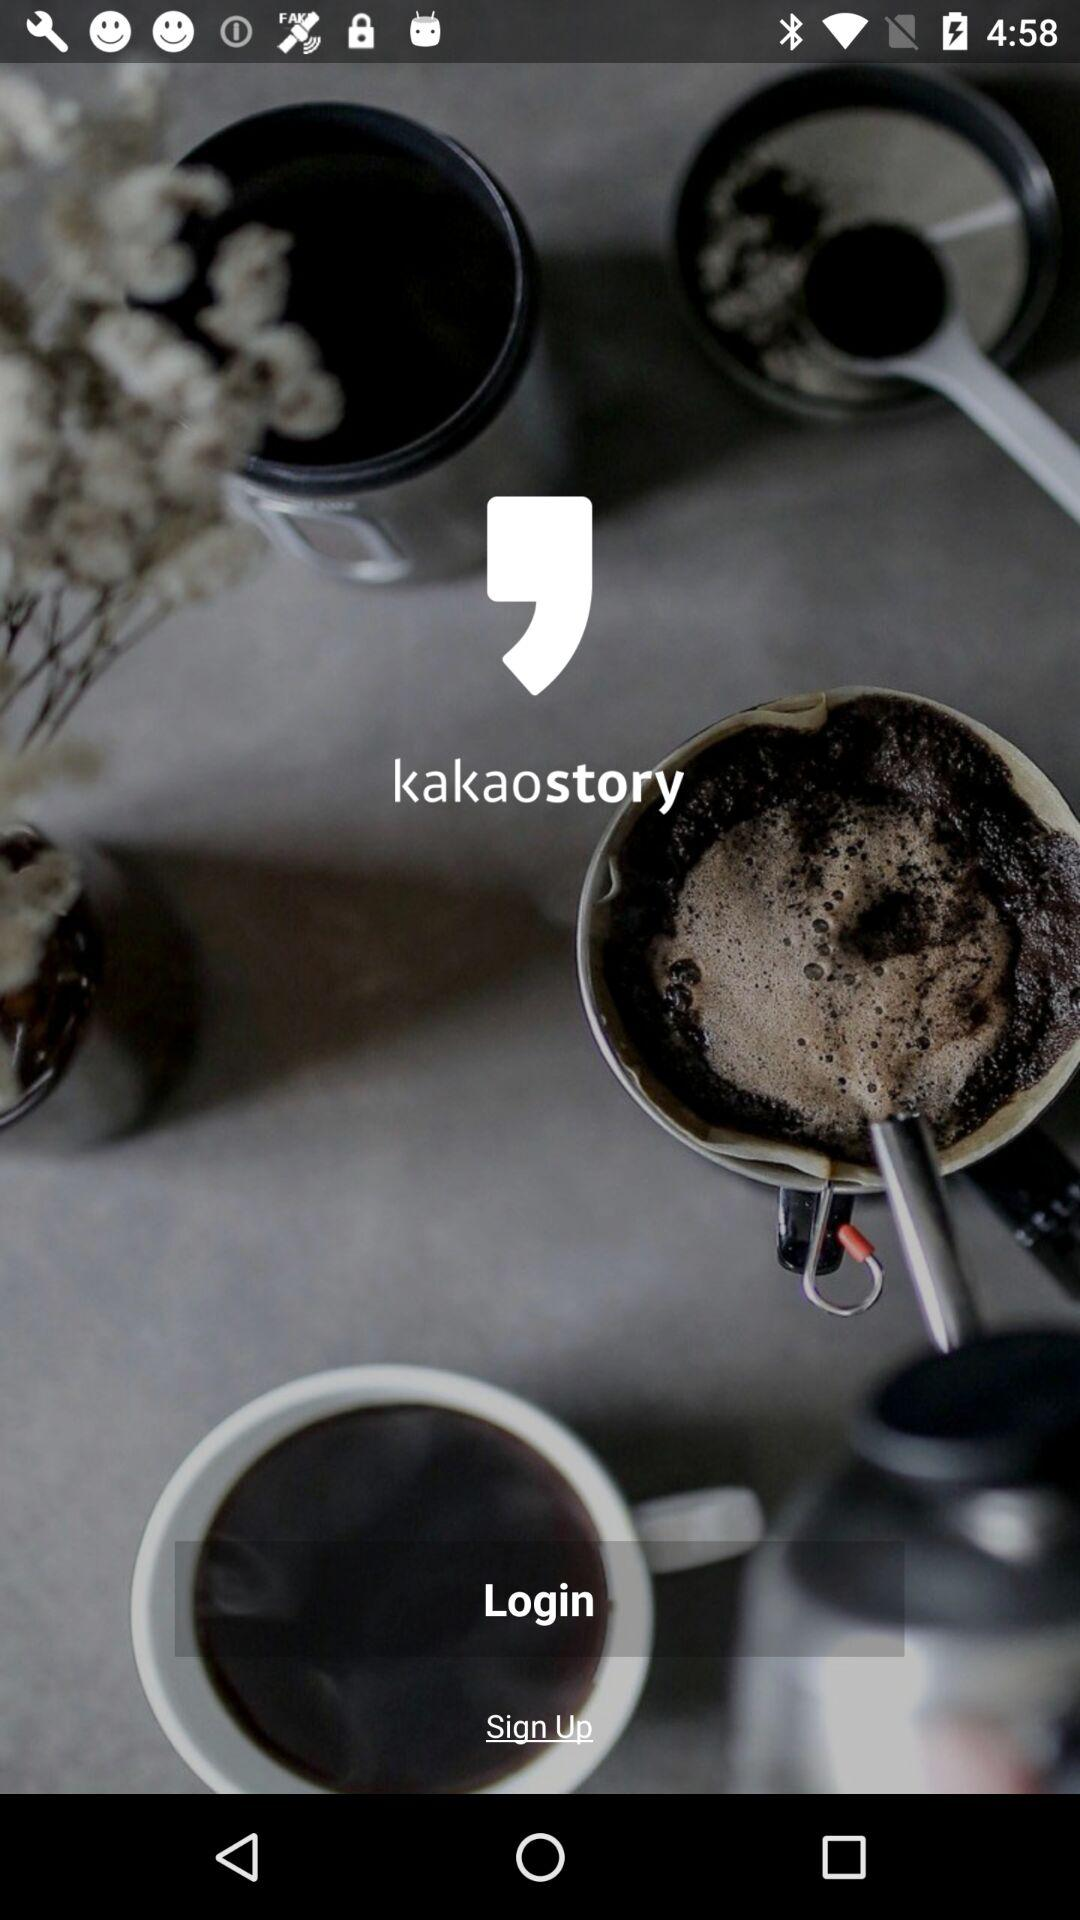What is the name of the application? The name of the application is "kakaostory". 